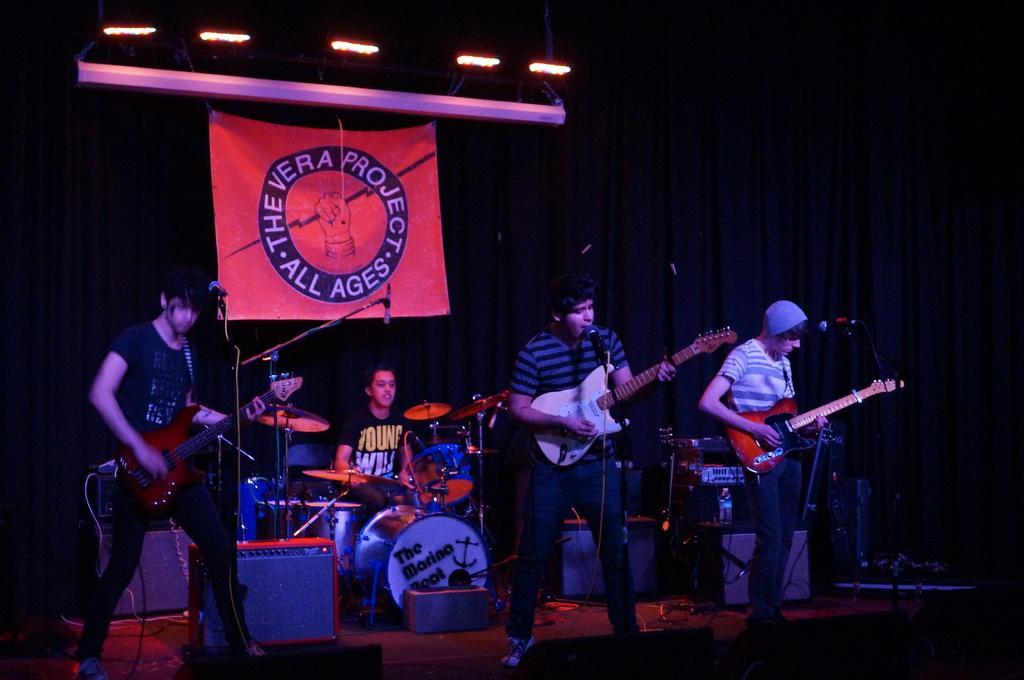Describe this image in one or two sentences. In this image there are group of persons who are playing musical instruments and at the top of the image there is a banner. 